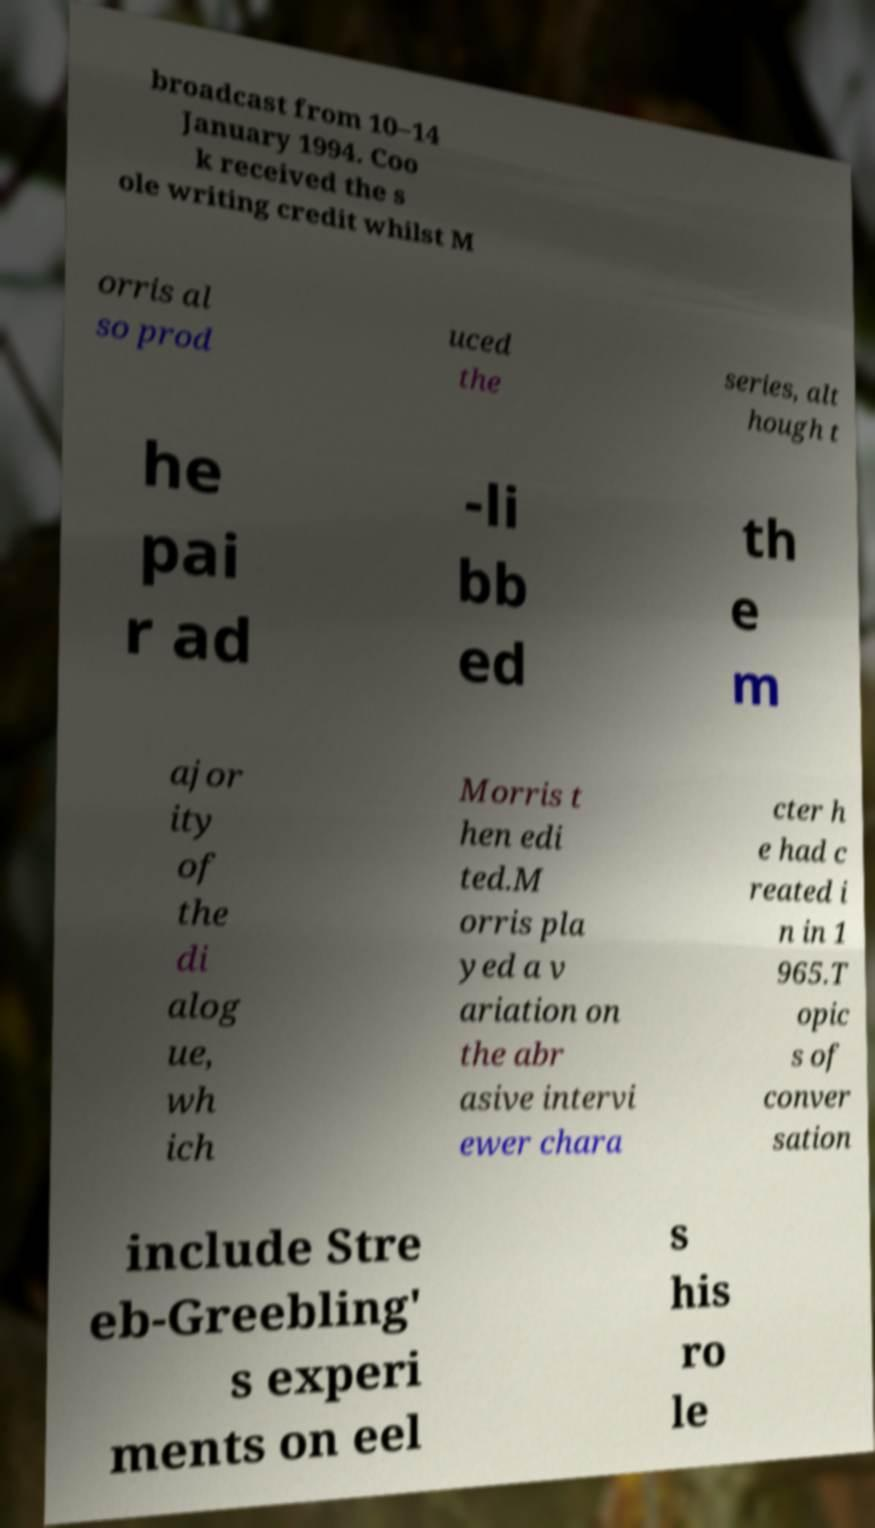Please read and relay the text visible in this image. What does it say? broadcast from 10–14 January 1994. Coo k received the s ole writing credit whilst M orris al so prod uced the series, alt hough t he pai r ad -li bb ed th e m ajor ity of the di alog ue, wh ich Morris t hen edi ted.M orris pla yed a v ariation on the abr asive intervi ewer chara cter h e had c reated i n in 1 965.T opic s of conver sation include Stre eb-Greebling' s experi ments on eel s his ro le 